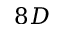Convert formula to latex. <formula><loc_0><loc_0><loc_500><loc_500>8 D</formula> 